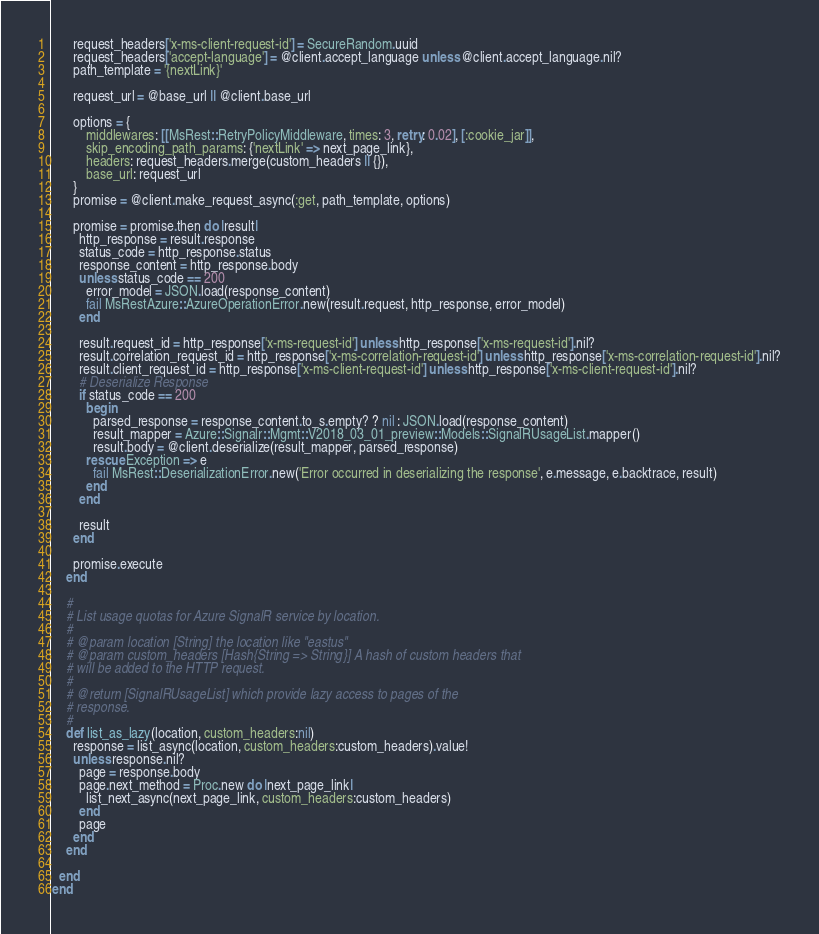Convert code to text. <code><loc_0><loc_0><loc_500><loc_500><_Ruby_>      request_headers['x-ms-client-request-id'] = SecureRandom.uuid
      request_headers['accept-language'] = @client.accept_language unless @client.accept_language.nil?
      path_template = '{nextLink}'

      request_url = @base_url || @client.base_url

      options = {
          middlewares: [[MsRest::RetryPolicyMiddleware, times: 3, retry: 0.02], [:cookie_jar]],
          skip_encoding_path_params: {'nextLink' => next_page_link},
          headers: request_headers.merge(custom_headers || {}),
          base_url: request_url
      }
      promise = @client.make_request_async(:get, path_template, options)

      promise = promise.then do |result|
        http_response = result.response
        status_code = http_response.status
        response_content = http_response.body
        unless status_code == 200
          error_model = JSON.load(response_content)
          fail MsRestAzure::AzureOperationError.new(result.request, http_response, error_model)
        end

        result.request_id = http_response['x-ms-request-id'] unless http_response['x-ms-request-id'].nil?
        result.correlation_request_id = http_response['x-ms-correlation-request-id'] unless http_response['x-ms-correlation-request-id'].nil?
        result.client_request_id = http_response['x-ms-client-request-id'] unless http_response['x-ms-client-request-id'].nil?
        # Deserialize Response
        if status_code == 200
          begin
            parsed_response = response_content.to_s.empty? ? nil : JSON.load(response_content)
            result_mapper = Azure::Signalr::Mgmt::V2018_03_01_preview::Models::SignalRUsageList.mapper()
            result.body = @client.deserialize(result_mapper, parsed_response)
          rescue Exception => e
            fail MsRest::DeserializationError.new('Error occurred in deserializing the response', e.message, e.backtrace, result)
          end
        end

        result
      end

      promise.execute
    end

    #
    # List usage quotas for Azure SignalR service by location.
    #
    # @param location [String] the location like "eastus"
    # @param custom_headers [Hash{String => String}] A hash of custom headers that
    # will be added to the HTTP request.
    #
    # @return [SignalRUsageList] which provide lazy access to pages of the
    # response.
    #
    def list_as_lazy(location, custom_headers:nil)
      response = list_async(location, custom_headers:custom_headers).value!
      unless response.nil?
        page = response.body
        page.next_method = Proc.new do |next_page_link|
          list_next_async(next_page_link, custom_headers:custom_headers)
        end
        page
      end
    end

  end
end
</code> 